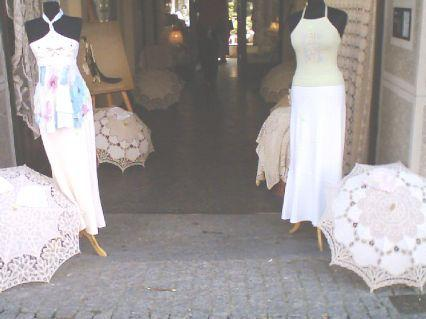Question: what is in the foreground?
Choices:
A. A building.
B. A tree.
C. Sidewalk.
D. A car.
Answer with the letter. Answer: C Question: how are they dressed?
Choices:
A. In shorts.
B. In flip flops.
C. In tank tops.
D. In women's clothes.
Answer with the letter. Answer: D Question: what are in front of the mannequins?
Choices:
A. A shoe stand.
B. Parasols.
C. Fake flowers.
D. A cart of samples.
Answer with the letter. Answer: B Question: what color are they?
Choices:
A. Red.
B. Blue.
C. Orange.
D. White.
Answer with the letter. Answer: D 